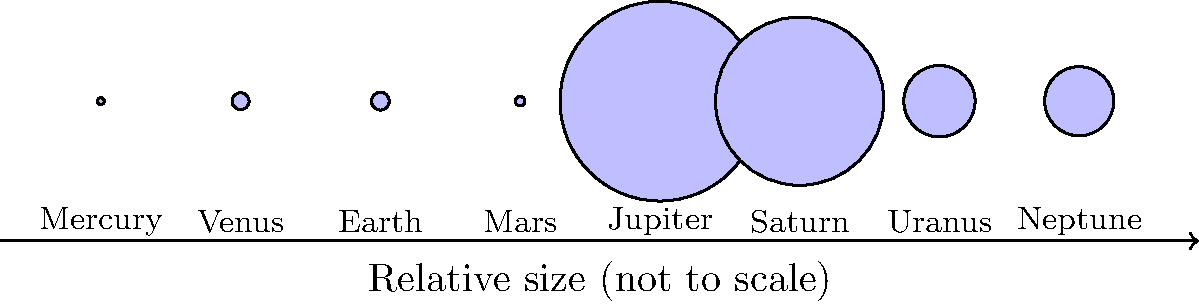Given the relative sizes of planets shown in the diagram, which planet would you propose as the most suitable candidate for future space exploration and potential resource extraction, considering factors such as size, proximity to Earth, and potential for scientific discoveries? Justify your answer in the context of allocating county resources for supporting space research initiatives. To answer this question, we need to consider several factors:

1. Size: Larger planets may have more diverse environments and resources.
2. Proximity to Earth: Closer planets are easier and less costly to reach.
3. Scientific potential: Planets with unique features offer more research opportunities.

Let's analyze each planet:

1. Mercury: Small and close to the Sun, but challenging to explore due to extreme temperatures.
2. Venus: Similar in size to Earth, but has a hostile environment with extreme heat and pressure.
3. Earth: Our home planet, already well-explored.
4. Mars: Smaller than Earth, but relatively close and has been a focus of recent exploration efforts.
5. Jupiter: Largest planet, but a gas giant with no solid surface for landing.
6. Saturn: Second-largest planet, also a gas giant with spectacular rings but difficult to explore.
7. Uranus and Neptune: Ice giants, far from Earth and challenging to reach.

Considering these factors, Mars emerges as the most suitable candidate for future space exploration and potential resource extraction:

1. It's the fourth-largest terrestrial planet, offering a substantial surface area for exploration.
2. It's relatively close to Earth, making missions more feasible and cost-effective.
3. Mars has shown evidence of past water activity and potential for harboring microbial life, making it scientifically interesting.
4. Its environment is less hostile than Venus or Mercury, allowing for longer-term missions and potential human habitation.
5. NASA and other space agencies have already invested significantly in Mars exploration, providing a foundation for future missions.

Allocating county resources to support Mars-focused space research initiatives could lead to technological advancements, economic opportunities, and increased public interest in science and space exploration.
Answer: Mars 